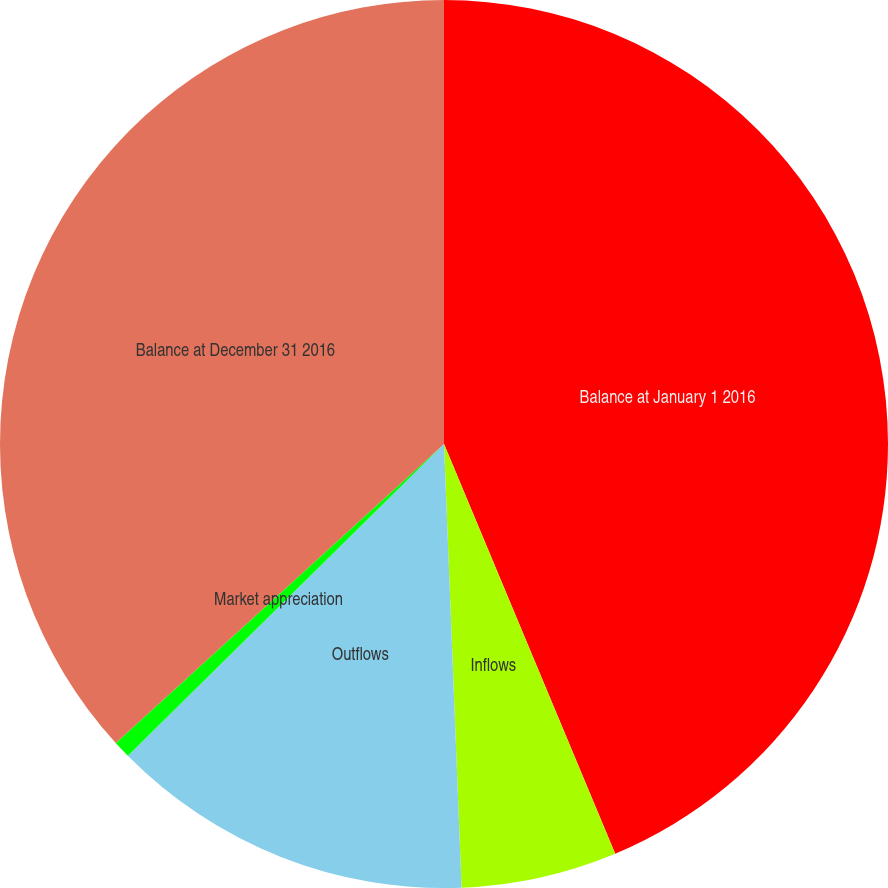Convert chart. <chart><loc_0><loc_0><loc_500><loc_500><pie_chart><fcel>Balance at January 1 2016<fcel>Inflows<fcel>Outflows<fcel>Market appreciation<fcel>Balance at December 31 2016<nl><fcel>43.7%<fcel>5.67%<fcel>13.24%<fcel>0.63%<fcel>36.76%<nl></chart> 